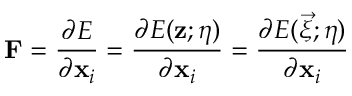<formula> <loc_0><loc_0><loc_500><loc_500>F = \frac { \partial E } { \partial x _ { i } } = \frac { \partial E ( z ; \eta ) } { \partial x _ { i } } = \frac { \partial E ( \vec { \xi } ; \eta ) } { \partial x _ { i } }</formula> 